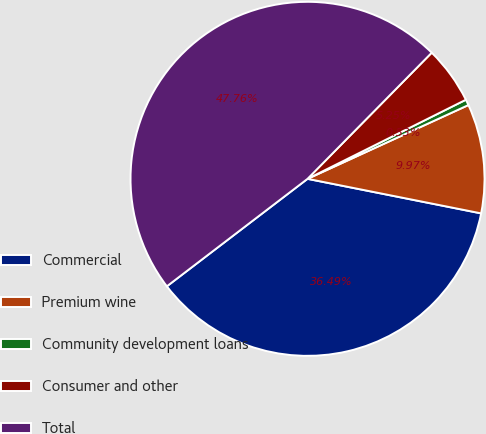Convert chart. <chart><loc_0><loc_0><loc_500><loc_500><pie_chart><fcel>Commercial<fcel>Premium wine<fcel>Community development loans<fcel>Consumer and other<fcel>Total<nl><fcel>36.49%<fcel>9.97%<fcel>0.53%<fcel>5.25%<fcel>47.76%<nl></chart> 